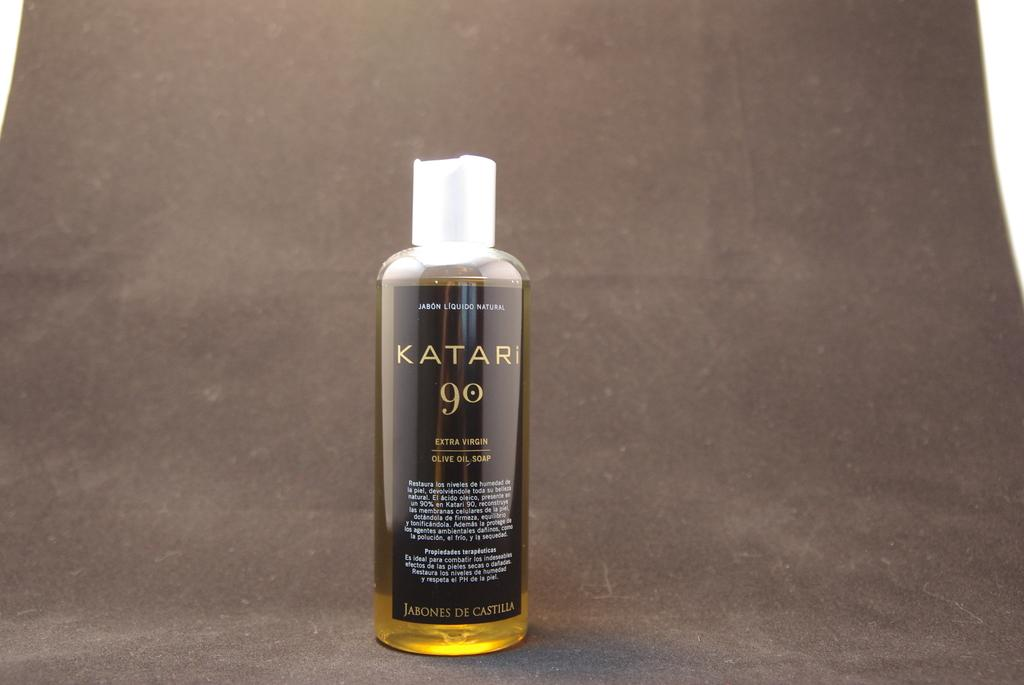What object can be seen in the image? There is a bottle in the image. What is written or printed on the bottle? The bottle has text on it. Where is the bottle located in the image? The bottle is placed on a surface. How many snails can be seen crawling on the bottle in the image? There are no snails visible on the bottle in the image. the image. 